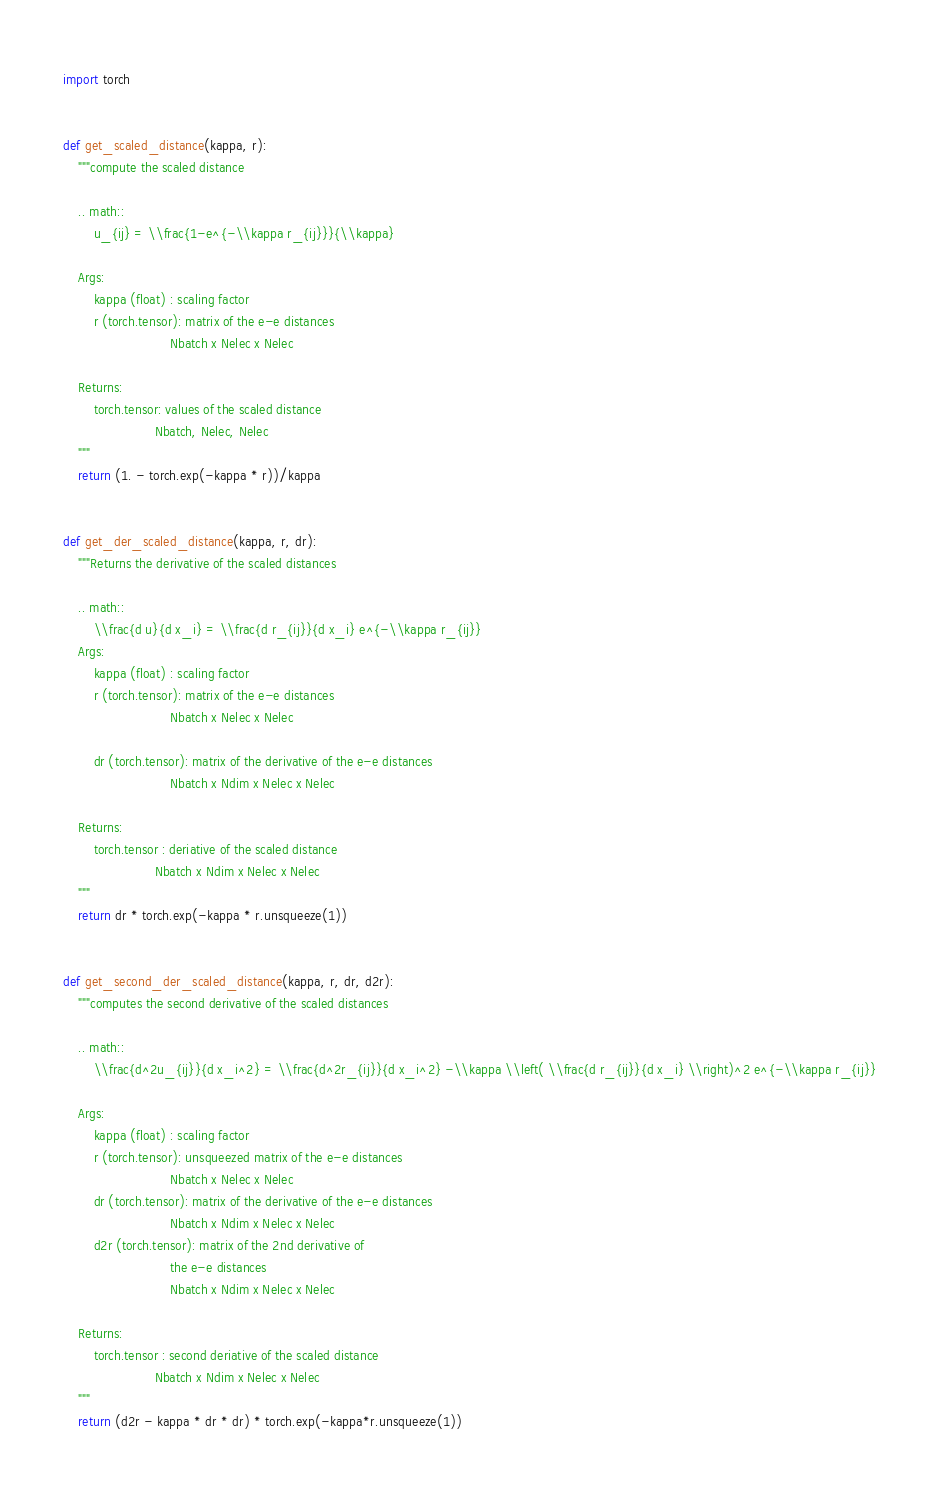<code> <loc_0><loc_0><loc_500><loc_500><_Python_>import torch


def get_scaled_distance(kappa, r):
    """compute the scaled distance

    .. math::
        u_{ij} = \\frac{1-e^{-\\kappa r_{ij}}}{\\kappa}

    Args:
        kappa (float) : scaling factor
        r (torch.tensor): matrix of the e-e distances
                            Nbatch x Nelec x Nelec

    Returns:
        torch.tensor: values of the scaled distance
                        Nbatch, Nelec, Nelec
    """
    return (1. - torch.exp(-kappa * r))/kappa


def get_der_scaled_distance(kappa, r, dr):
    """Returns the derivative of the scaled distances

    .. math::
        \\frac{d u}{d x_i} = \\frac{d r_{ij}}{d x_i} e^{-\\kappa r_{ij}}
    Args:
        kappa (float) : scaling factor
        r (torch.tensor): matrix of the e-e distances
                            Nbatch x Nelec x Nelec

        dr (torch.tensor): matrix of the derivative of the e-e distances
                            Nbatch x Ndim x Nelec x Nelec

    Returns:
        torch.tensor : deriative of the scaled distance
                        Nbatch x Ndim x Nelec x Nelec
    """
    return dr * torch.exp(-kappa * r.unsqueeze(1))


def get_second_der_scaled_distance(kappa, r, dr, d2r):
    """computes the second derivative of the scaled distances

    .. math::
        \\frac{d^2u_{ij}}{d x_i^2} = \\frac{d^2r_{ij}}{d x_i^2} -\\kappa \\left( \\frac{d r_{ij}}{d x_i} \\right)^2 e^{-\\kappa r_{ij}}

    Args:
        kappa (float) : scaling factor
        r (torch.tensor): unsqueezed matrix of the e-e distances
                            Nbatch x Nelec x Nelec
        dr (torch.tensor): matrix of the derivative of the e-e distances
                            Nbatch x Ndim x Nelec x Nelec
        d2r (torch.tensor): matrix of the 2nd derivative of
                            the e-e distances
                            Nbatch x Ndim x Nelec x Nelec

    Returns:
        torch.tensor : second deriative of the scaled distance
                        Nbatch x Ndim x Nelec x Nelec
    """
    return (d2r - kappa * dr * dr) * torch.exp(-kappa*r.unsqueeze(1))
</code> 